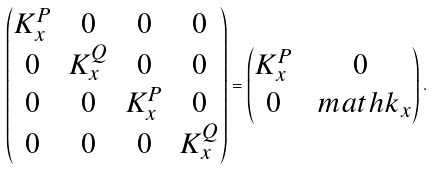Convert formula to latex. <formula><loc_0><loc_0><loc_500><loc_500>\begin{pmatrix} K ^ { P } _ { x } & 0 & 0 & 0 \\ 0 & K ^ { Q } _ { x } & 0 & 0 \\ 0 & 0 & K ^ { P } _ { x } & 0 \\ 0 & 0 & 0 & K ^ { Q } _ { x } \end{pmatrix} = \begin{pmatrix} K ^ { P } _ { x } & 0 \\ 0 & \ m a t h k _ { x } \end{pmatrix} .</formula> 